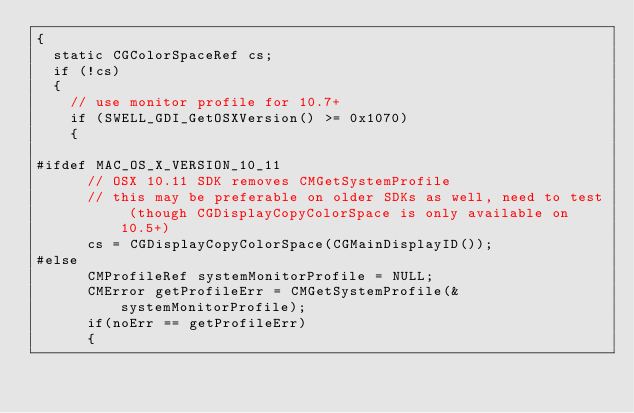Convert code to text. <code><loc_0><loc_0><loc_500><loc_500><_ObjectiveC_>{
  static CGColorSpaceRef cs;
  if (!cs)
  {
    // use monitor profile for 10.7+
    if (SWELL_GDI_GetOSXVersion() >= 0x1070)
    {

#ifdef MAC_OS_X_VERSION_10_11
      // OSX 10.11 SDK removes CMGetSystemProfile
      // this may be preferable on older SDKs as well, need to test (though CGDisplayCopyColorSpace is only available on 10.5+)
      cs = CGDisplayCopyColorSpace(CGMainDisplayID());
#else
      CMProfileRef systemMonitorProfile = NULL;
      CMError getProfileErr = CMGetSystemProfile(&systemMonitorProfile);
      if(noErr == getProfileErr)
      {</code> 